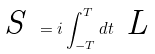Convert formula to latex. <formula><loc_0><loc_0><loc_500><loc_500>\emph { S } = i \int _ { - T } ^ { T } d t \emph { L }</formula> 